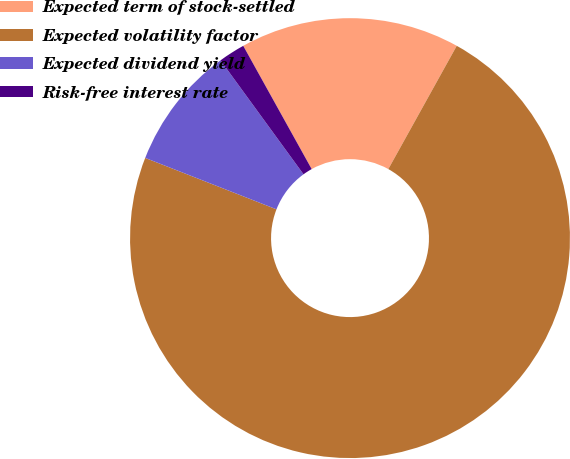Convert chart to OTSL. <chart><loc_0><loc_0><loc_500><loc_500><pie_chart><fcel>Expected term of stock-settled<fcel>Expected volatility factor<fcel>Expected dividend yield<fcel>Risk-free interest rate<nl><fcel>16.13%<fcel>72.87%<fcel>9.04%<fcel>1.95%<nl></chart> 